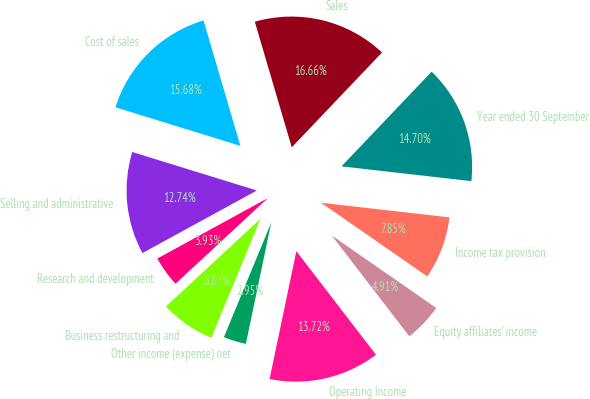<chart> <loc_0><loc_0><loc_500><loc_500><pie_chart><fcel>Year ended 30 September<fcel>Sales<fcel>Cost of sales<fcel>Selling and administrative<fcel>Research and development<fcel>Business restructuring and<fcel>Other income (expense) net<fcel>Operating Income<fcel>Equity affiliates' income<fcel>Income tax provision<nl><fcel>14.7%<fcel>16.66%<fcel>15.68%<fcel>12.74%<fcel>3.93%<fcel>6.87%<fcel>2.95%<fcel>13.72%<fcel>4.91%<fcel>7.85%<nl></chart> 